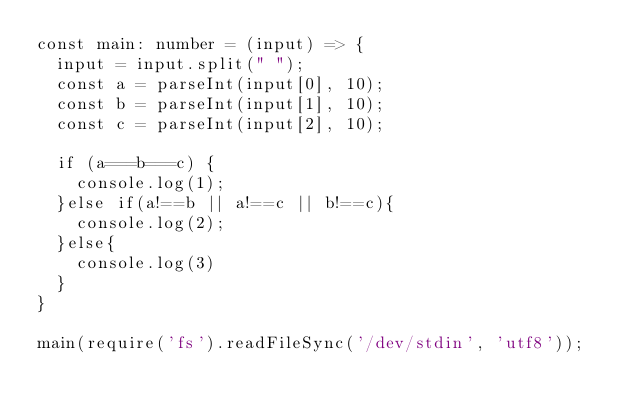Convert code to text. <code><loc_0><loc_0><loc_500><loc_500><_TypeScript_>const main: number = (input) => {
  input = input.split(" ");
  const a = parseInt(input[0], 10);
  const b = parseInt(input[1], 10);
  const c = parseInt(input[2], 10);
  
  if (a===b===c) {
    console.log(1);
  }else if(a!==b || a!==c || b!==c){
    console.log(2);
  }else{
    console.log(3)
  }
}
  
main(require('fs').readFileSync('/dev/stdin', 'utf8'));</code> 